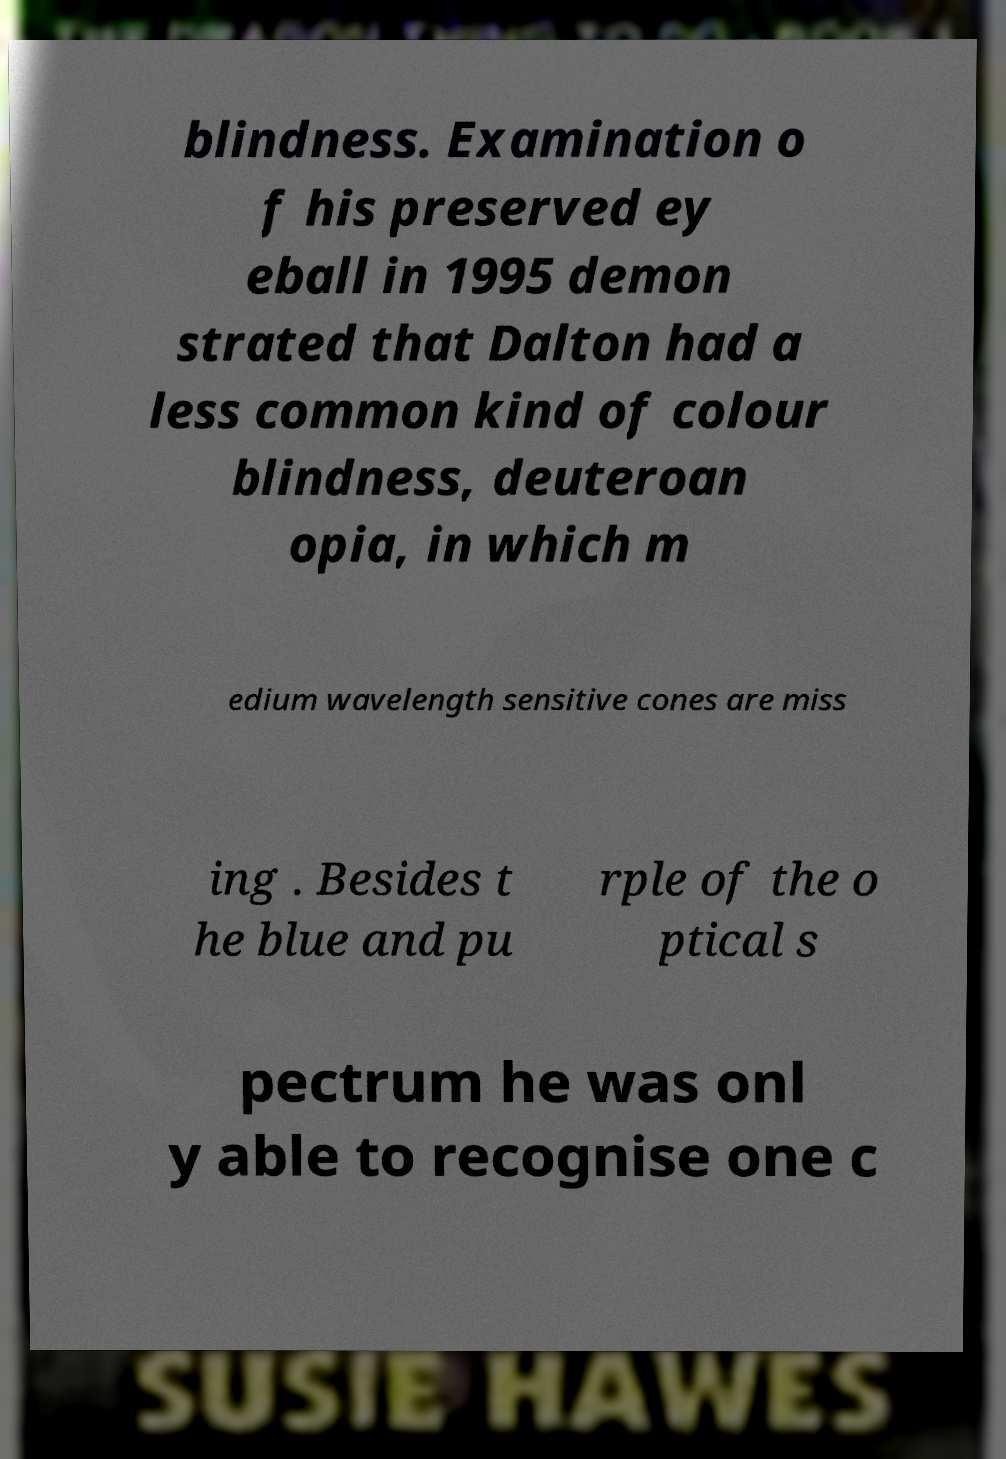There's text embedded in this image that I need extracted. Can you transcribe it verbatim? blindness. Examination o f his preserved ey eball in 1995 demon strated that Dalton had a less common kind of colour blindness, deuteroan opia, in which m edium wavelength sensitive cones are miss ing . Besides t he blue and pu rple of the o ptical s pectrum he was onl y able to recognise one c 